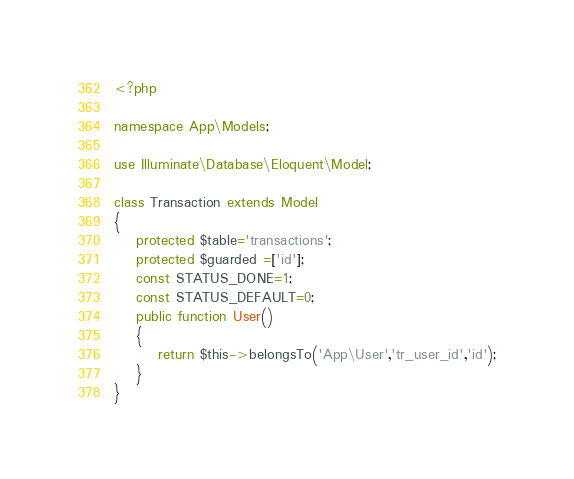Convert code to text. <code><loc_0><loc_0><loc_500><loc_500><_PHP_><?php

namespace App\Models;

use Illuminate\Database\Eloquent\Model;

class Transaction extends Model
{
    protected $table='transactions';
    protected $guarded =['id'];
    const STATUS_DONE=1;
    const STATUS_DEFAULT=0;
    public function User()
    {
        return $this->belongsTo('App\User','tr_user_id','id');
    }
}
</code> 